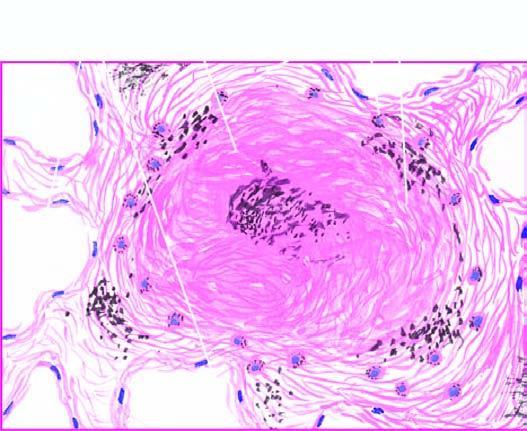does polarising microscopy in photomicrograph on right show bright fibres of silica?
Answer the question using a single word or phrase. Yes 